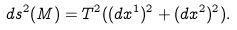<formula> <loc_0><loc_0><loc_500><loc_500>d s ^ { 2 } ( M ) = T ^ { 2 } ( ( d x ^ { 1 } ) ^ { 2 } + ( d x ^ { 2 } ) ^ { 2 } ) .</formula> 